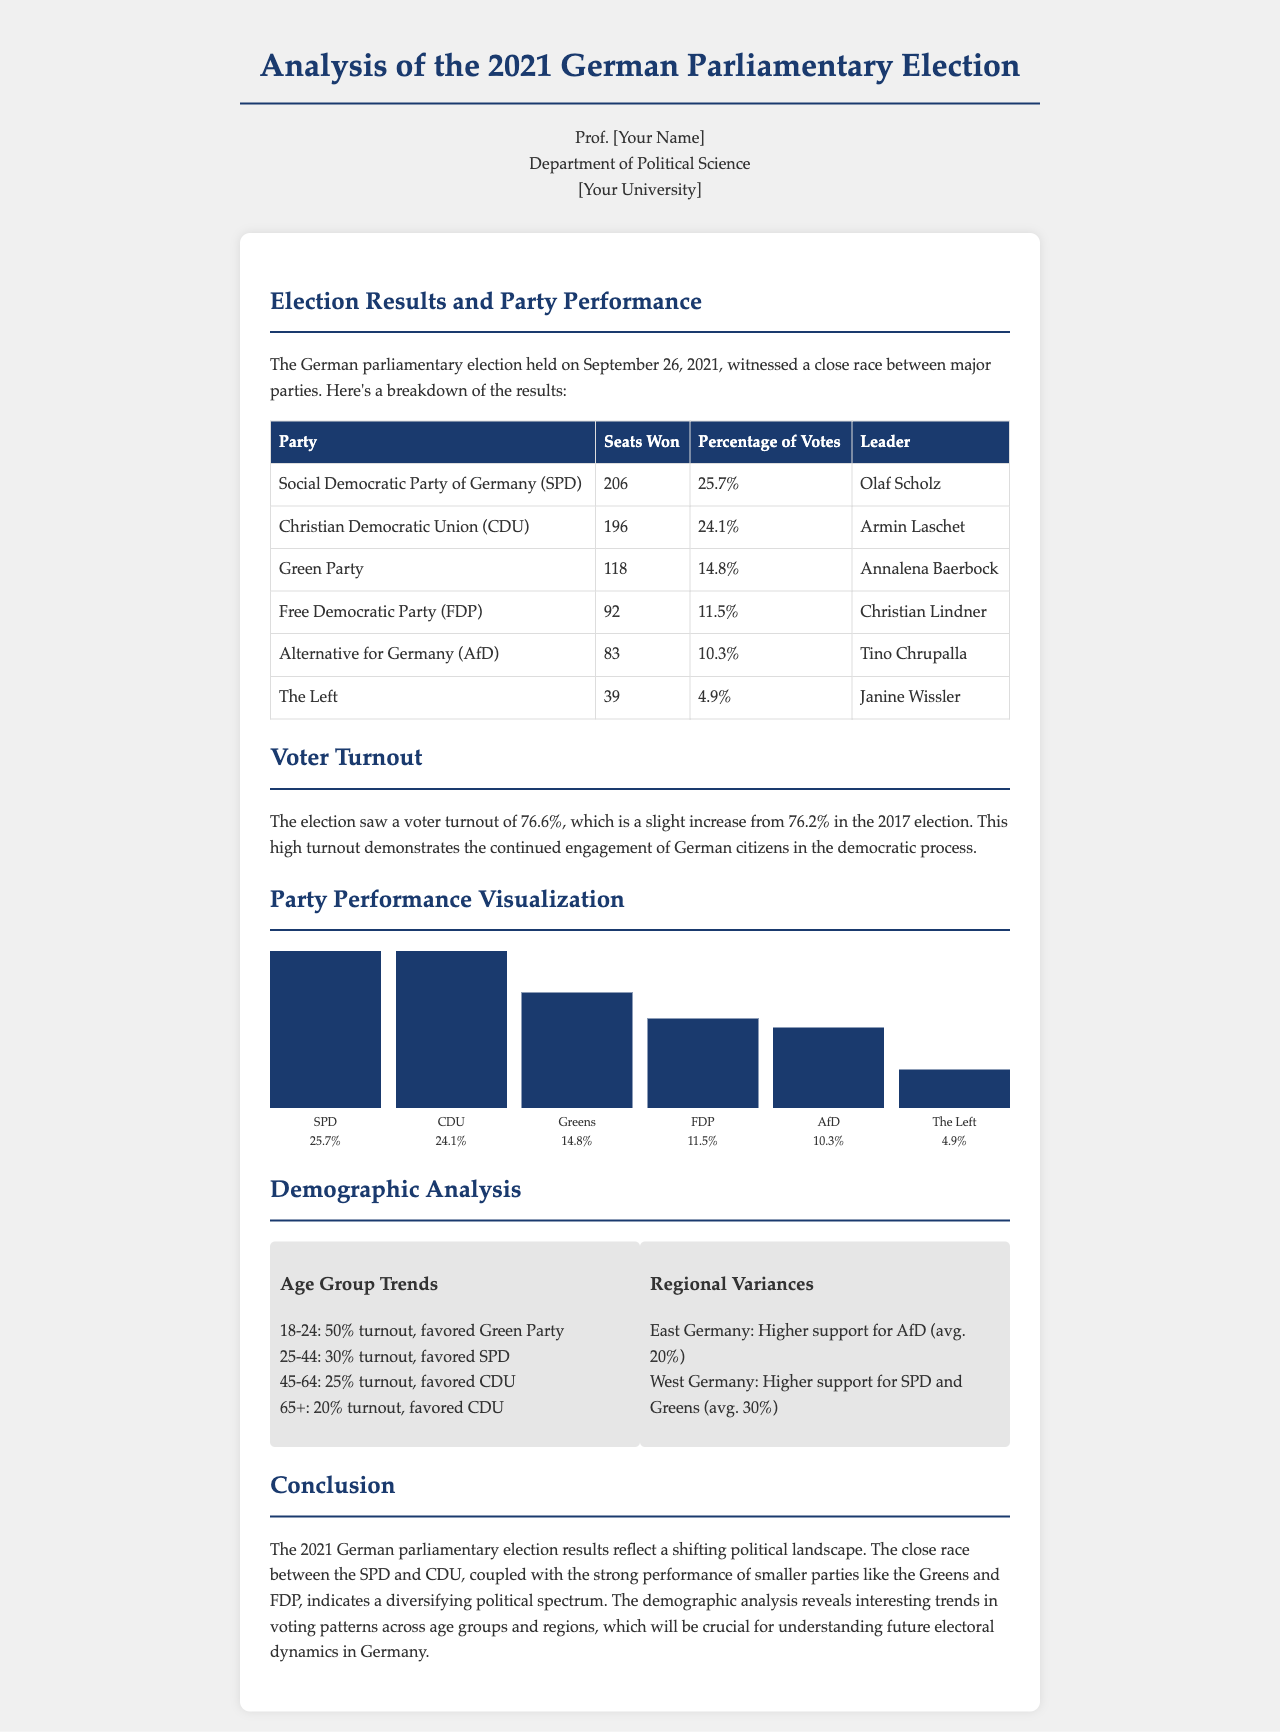What was the date of the German parliamentary election? The date of the election is clearly mentioned in the document as September 26, 2021.
Answer: September 26, 2021 How many seats did the Social Democratic Party of Germany (SPD) win? The document provides a specific number of seats won by the SPD, which is mentioned in the table.
Answer: 206 What was the voter turnout percentage in this election? The document states that the voter turnout was 76.6%, which is an important statistic in assessing electoral engagement.
Answer: 76.6% Which party had the least percentage of votes? The table lists the percentage of votes for each party, indicating the party with the least amount, which is The Left.
Answer: The Left What demographic group favored the Green Party? The document states that the 18-24 age group had a 50% turnout and favored the Green Party.
Answer: 18-24 Which region showed higher support for the AfD? The demographic analysis section highlights that East Germany showed higher support for AfD, indicating regional variances in party support.
Answer: East Germany Who was the leader of the Christian Democratic Union (CDU)? The document specifies the name of the CDU leader, which is relevant for understanding party representation.
Answer: Armin Laschet What was the average support for SPD and Greens in West Germany? The document provides quantitative data about average support for specific parties in regions, specifically mentioning West Germany's support for SPD and Greens.
Answer: 30% 